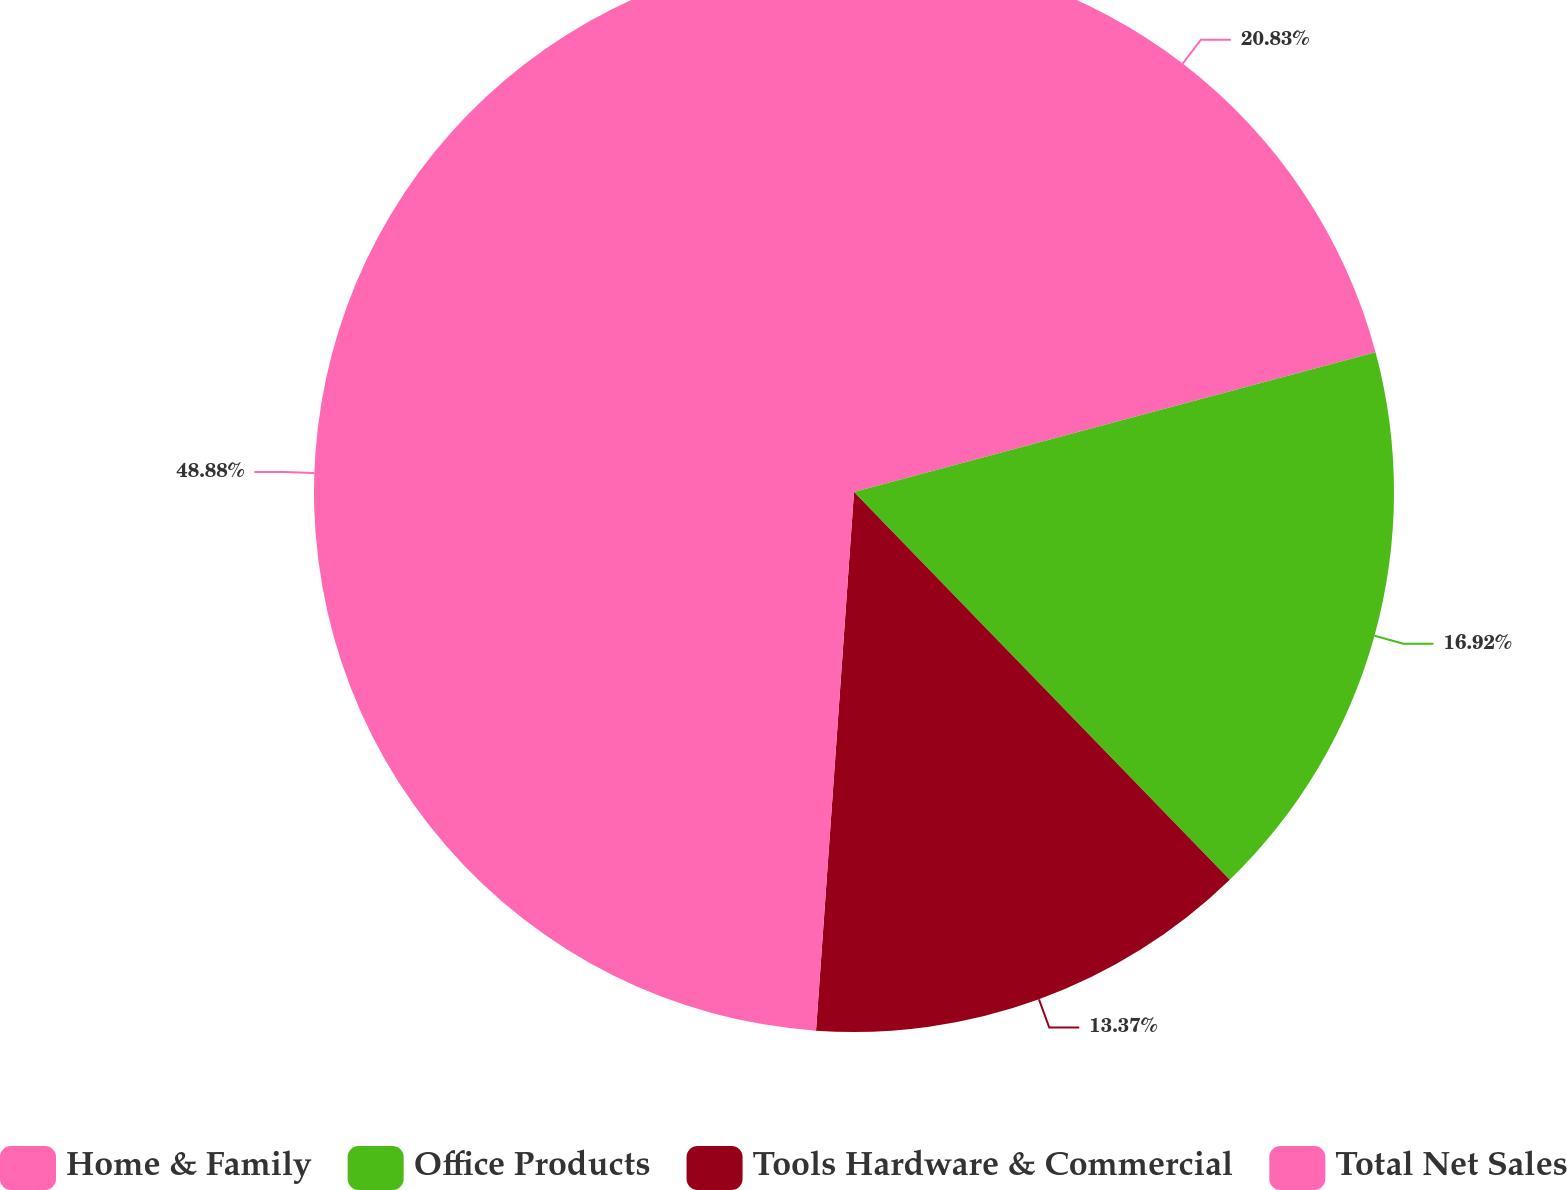Convert chart. <chart><loc_0><loc_0><loc_500><loc_500><pie_chart><fcel>Home & Family<fcel>Office Products<fcel>Tools Hardware & Commercial<fcel>Total Net Sales<nl><fcel>20.83%<fcel>16.92%<fcel>13.37%<fcel>48.88%<nl></chart> 